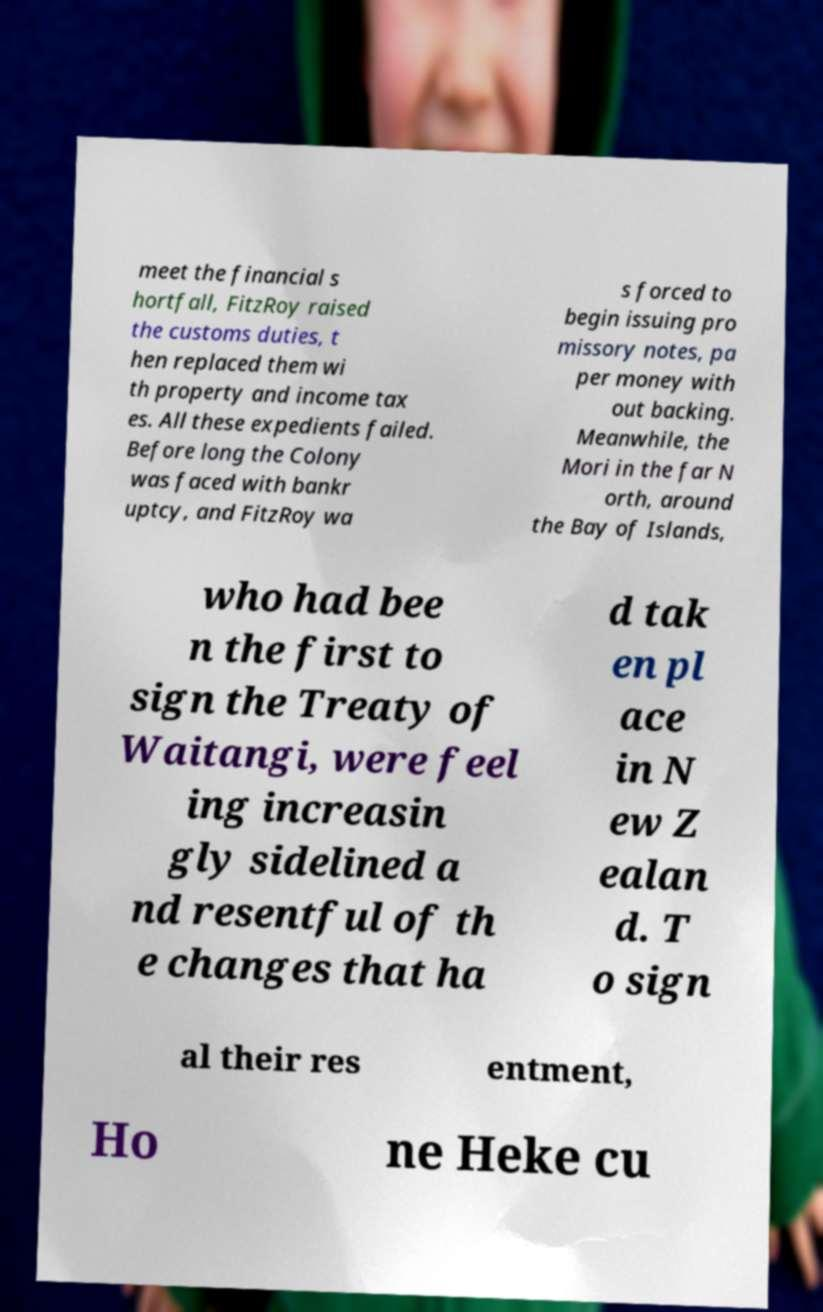Could you assist in decoding the text presented in this image and type it out clearly? meet the financial s hortfall, FitzRoy raised the customs duties, t hen replaced them wi th property and income tax es. All these expedients failed. Before long the Colony was faced with bankr uptcy, and FitzRoy wa s forced to begin issuing pro missory notes, pa per money with out backing. Meanwhile, the Mori in the far N orth, around the Bay of Islands, who had bee n the first to sign the Treaty of Waitangi, were feel ing increasin gly sidelined a nd resentful of th e changes that ha d tak en pl ace in N ew Z ealan d. T o sign al their res entment, Ho ne Heke cu 